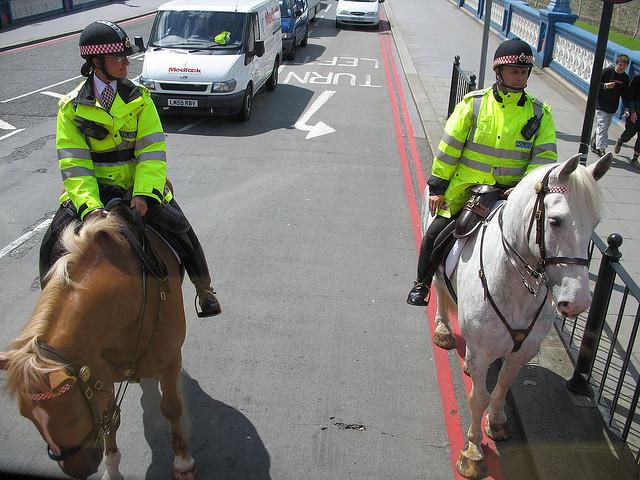What turning lane are they in?
Be succinct. Left. What are they riding on?
Concise answer only. Horses. What color are the jackets?
Keep it brief. Green. 